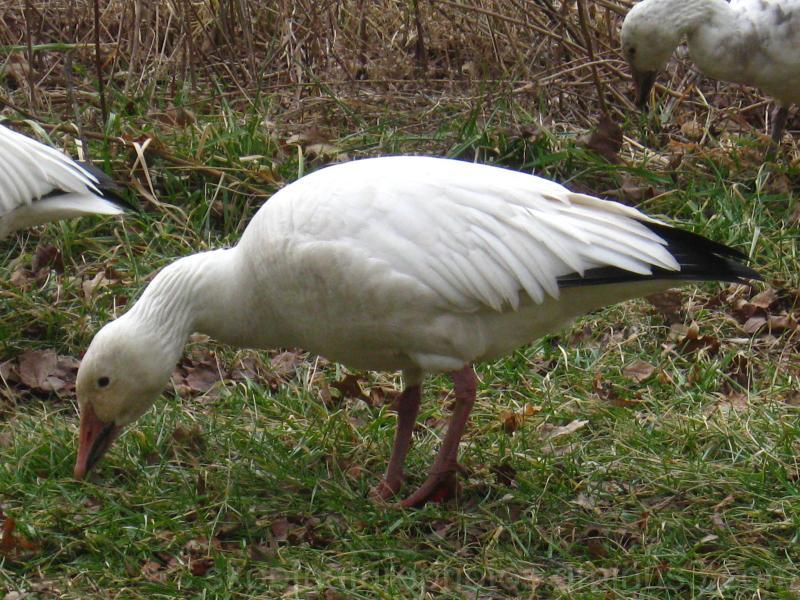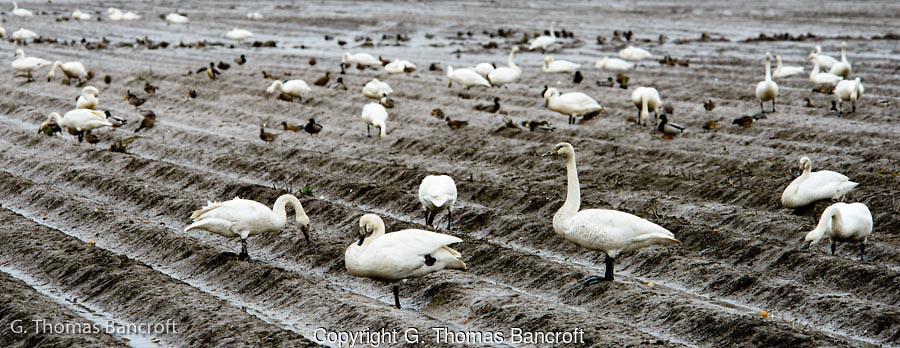The first image is the image on the left, the second image is the image on the right. For the images displayed, is the sentence "At least one of the images has geese in brown grass." factually correct? Answer yes or no. No. The first image is the image on the left, the second image is the image on the right. Assess this claim about the two images: "There are no more than three birds in the left image.". Correct or not? Answer yes or no. Yes. 